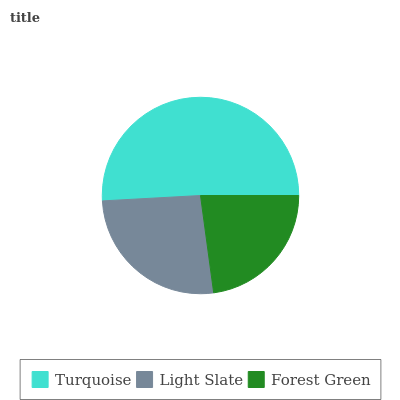Is Forest Green the minimum?
Answer yes or no. Yes. Is Turquoise the maximum?
Answer yes or no. Yes. Is Light Slate the minimum?
Answer yes or no. No. Is Light Slate the maximum?
Answer yes or no. No. Is Turquoise greater than Light Slate?
Answer yes or no. Yes. Is Light Slate less than Turquoise?
Answer yes or no. Yes. Is Light Slate greater than Turquoise?
Answer yes or no. No. Is Turquoise less than Light Slate?
Answer yes or no. No. Is Light Slate the high median?
Answer yes or no. Yes. Is Light Slate the low median?
Answer yes or no. Yes. Is Forest Green the high median?
Answer yes or no. No. Is Forest Green the low median?
Answer yes or no. No. 